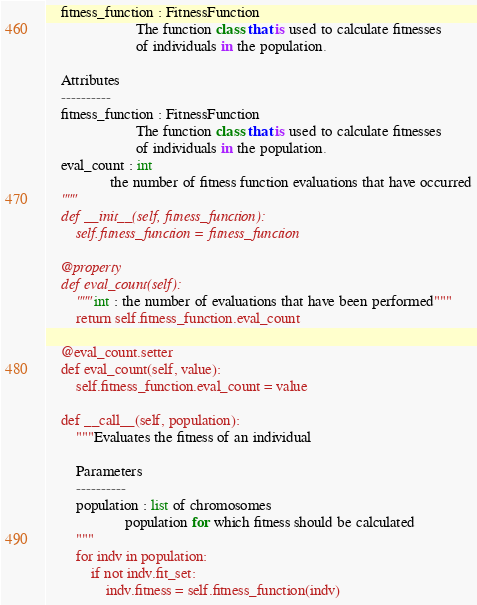Convert code to text. <code><loc_0><loc_0><loc_500><loc_500><_Python_>    fitness_function : FitnessFunction
                        The function class that is used to calculate fitnesses
                        of individuals in the population.

    Attributes
    ----------
    fitness_function : FitnessFunction
                        The function class that is used to calculate fitnesses
                        of individuals in the population.
    eval_count : int
                 the number of fitness function evaluations that have occurred
    """
    def __init__(self, fitness_function):
        self.fitness_function = fitness_function

    @property
    def eval_count(self):
        """int : the number of evaluations that have been performed"""
        return self.fitness_function.eval_count

    @eval_count.setter
    def eval_count(self, value):
        self.fitness_function.eval_count = value

    def __call__(self, population):
        """Evaluates the fitness of an individual

        Parameters
        ----------
        population : list of chromosomes
                     population for which fitness should be calculated
        """
        for indv in population:
            if not indv.fit_set:
                indv.fitness = self.fitness_function(indv)
</code> 